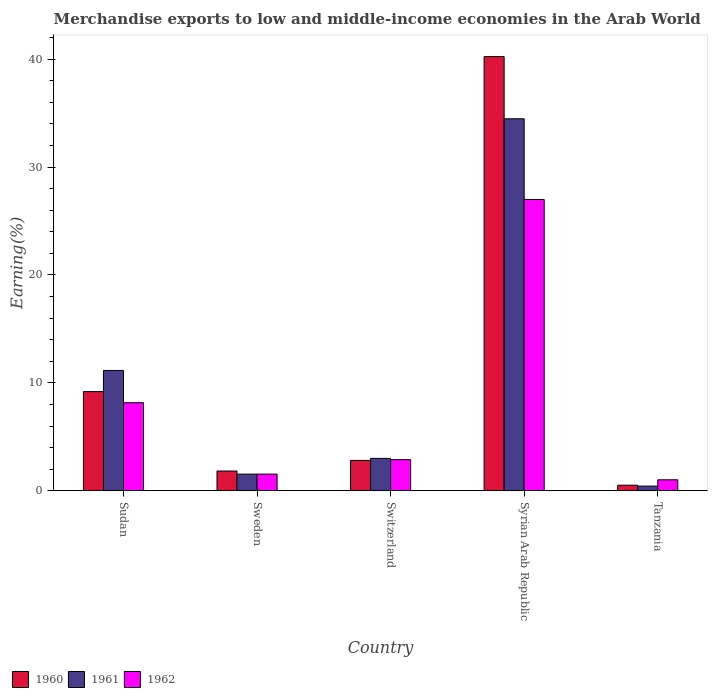What is the label of the 5th group of bars from the left?
Provide a succinct answer. Tanzania. What is the percentage of amount earned from merchandise exports in 1960 in Syrian Arab Republic?
Provide a succinct answer. 40.24. Across all countries, what is the maximum percentage of amount earned from merchandise exports in 1960?
Offer a very short reply. 40.24. Across all countries, what is the minimum percentage of amount earned from merchandise exports in 1962?
Your answer should be compact. 1.02. In which country was the percentage of amount earned from merchandise exports in 1961 maximum?
Keep it short and to the point. Syrian Arab Republic. In which country was the percentage of amount earned from merchandise exports in 1962 minimum?
Ensure brevity in your answer.  Tanzania. What is the total percentage of amount earned from merchandise exports in 1960 in the graph?
Offer a very short reply. 54.6. What is the difference between the percentage of amount earned from merchandise exports in 1961 in Sweden and that in Tanzania?
Ensure brevity in your answer.  1.11. What is the difference between the percentage of amount earned from merchandise exports in 1962 in Sudan and the percentage of amount earned from merchandise exports in 1961 in Syrian Arab Republic?
Keep it short and to the point. -26.32. What is the average percentage of amount earned from merchandise exports in 1962 per country?
Provide a succinct answer. 8.12. What is the difference between the percentage of amount earned from merchandise exports of/in 1962 and percentage of amount earned from merchandise exports of/in 1960 in Sudan?
Your response must be concise. -1.03. What is the ratio of the percentage of amount earned from merchandise exports in 1962 in Sudan to that in Switzerland?
Make the answer very short. 2.83. Is the percentage of amount earned from merchandise exports in 1961 in Switzerland less than that in Tanzania?
Your response must be concise. No. Is the difference between the percentage of amount earned from merchandise exports in 1962 in Sudan and Tanzania greater than the difference between the percentage of amount earned from merchandise exports in 1960 in Sudan and Tanzania?
Give a very brief answer. No. What is the difference between the highest and the second highest percentage of amount earned from merchandise exports in 1961?
Ensure brevity in your answer.  -31.48. What is the difference between the highest and the lowest percentage of amount earned from merchandise exports in 1962?
Make the answer very short. 25.98. In how many countries, is the percentage of amount earned from merchandise exports in 1961 greater than the average percentage of amount earned from merchandise exports in 1961 taken over all countries?
Your answer should be compact. 2. What does the 2nd bar from the left in Syrian Arab Republic represents?
Offer a terse response. 1961. What does the 2nd bar from the right in Sudan represents?
Your answer should be compact. 1961. How many bars are there?
Offer a terse response. 15. Are all the bars in the graph horizontal?
Your answer should be very brief. No. How many countries are there in the graph?
Provide a short and direct response. 5. Does the graph contain grids?
Keep it short and to the point. No. How many legend labels are there?
Provide a short and direct response. 3. What is the title of the graph?
Make the answer very short. Merchandise exports to low and middle-income economies in the Arab World. Does "2013" appear as one of the legend labels in the graph?
Your answer should be compact. No. What is the label or title of the Y-axis?
Offer a very short reply. Earning(%). What is the Earning(%) of 1960 in Sudan?
Provide a succinct answer. 9.19. What is the Earning(%) of 1961 in Sudan?
Offer a terse response. 11.15. What is the Earning(%) in 1962 in Sudan?
Provide a succinct answer. 8.16. What is the Earning(%) in 1960 in Sweden?
Your answer should be very brief. 1.83. What is the Earning(%) of 1961 in Sweden?
Offer a very short reply. 1.54. What is the Earning(%) of 1962 in Sweden?
Your response must be concise. 1.55. What is the Earning(%) in 1960 in Switzerland?
Offer a very short reply. 2.82. What is the Earning(%) in 1961 in Switzerland?
Your answer should be compact. 3. What is the Earning(%) in 1962 in Switzerland?
Make the answer very short. 2.89. What is the Earning(%) of 1960 in Syrian Arab Republic?
Your answer should be compact. 40.24. What is the Earning(%) of 1961 in Syrian Arab Republic?
Your answer should be compact. 34.48. What is the Earning(%) of 1962 in Syrian Arab Republic?
Offer a terse response. 27. What is the Earning(%) in 1960 in Tanzania?
Keep it short and to the point. 0.52. What is the Earning(%) of 1961 in Tanzania?
Give a very brief answer. 0.43. What is the Earning(%) of 1962 in Tanzania?
Your answer should be compact. 1.02. Across all countries, what is the maximum Earning(%) in 1960?
Keep it short and to the point. 40.24. Across all countries, what is the maximum Earning(%) in 1961?
Your answer should be compact. 34.48. Across all countries, what is the maximum Earning(%) of 1962?
Keep it short and to the point. 27. Across all countries, what is the minimum Earning(%) of 1960?
Your answer should be compact. 0.52. Across all countries, what is the minimum Earning(%) in 1961?
Ensure brevity in your answer.  0.43. Across all countries, what is the minimum Earning(%) of 1962?
Offer a very short reply. 1.02. What is the total Earning(%) in 1960 in the graph?
Offer a very short reply. 54.6. What is the total Earning(%) of 1961 in the graph?
Your response must be concise. 50.62. What is the total Earning(%) in 1962 in the graph?
Your answer should be compact. 40.62. What is the difference between the Earning(%) of 1960 in Sudan and that in Sweden?
Provide a succinct answer. 7.36. What is the difference between the Earning(%) of 1961 in Sudan and that in Sweden?
Give a very brief answer. 9.61. What is the difference between the Earning(%) of 1962 in Sudan and that in Sweden?
Provide a succinct answer. 6.62. What is the difference between the Earning(%) in 1960 in Sudan and that in Switzerland?
Give a very brief answer. 6.37. What is the difference between the Earning(%) in 1961 in Sudan and that in Switzerland?
Offer a terse response. 8.15. What is the difference between the Earning(%) in 1962 in Sudan and that in Switzerland?
Ensure brevity in your answer.  5.28. What is the difference between the Earning(%) of 1960 in Sudan and that in Syrian Arab Republic?
Offer a terse response. -31.05. What is the difference between the Earning(%) in 1961 in Sudan and that in Syrian Arab Republic?
Offer a terse response. -23.32. What is the difference between the Earning(%) of 1962 in Sudan and that in Syrian Arab Republic?
Offer a very short reply. -18.84. What is the difference between the Earning(%) in 1960 in Sudan and that in Tanzania?
Keep it short and to the point. 8.67. What is the difference between the Earning(%) in 1961 in Sudan and that in Tanzania?
Ensure brevity in your answer.  10.72. What is the difference between the Earning(%) in 1962 in Sudan and that in Tanzania?
Provide a succinct answer. 7.15. What is the difference between the Earning(%) in 1960 in Sweden and that in Switzerland?
Your answer should be very brief. -0.99. What is the difference between the Earning(%) in 1961 in Sweden and that in Switzerland?
Your answer should be very brief. -1.46. What is the difference between the Earning(%) of 1962 in Sweden and that in Switzerland?
Offer a very short reply. -1.34. What is the difference between the Earning(%) of 1960 in Sweden and that in Syrian Arab Republic?
Make the answer very short. -38.41. What is the difference between the Earning(%) of 1961 in Sweden and that in Syrian Arab Republic?
Provide a short and direct response. -32.94. What is the difference between the Earning(%) in 1962 in Sweden and that in Syrian Arab Republic?
Your answer should be very brief. -25.45. What is the difference between the Earning(%) of 1960 in Sweden and that in Tanzania?
Provide a short and direct response. 1.31. What is the difference between the Earning(%) of 1961 in Sweden and that in Tanzania?
Keep it short and to the point. 1.11. What is the difference between the Earning(%) in 1962 in Sweden and that in Tanzania?
Provide a succinct answer. 0.53. What is the difference between the Earning(%) of 1960 in Switzerland and that in Syrian Arab Republic?
Make the answer very short. -37.43. What is the difference between the Earning(%) of 1961 in Switzerland and that in Syrian Arab Republic?
Offer a terse response. -31.48. What is the difference between the Earning(%) in 1962 in Switzerland and that in Syrian Arab Republic?
Provide a short and direct response. -24.12. What is the difference between the Earning(%) in 1960 in Switzerland and that in Tanzania?
Keep it short and to the point. 2.3. What is the difference between the Earning(%) in 1961 in Switzerland and that in Tanzania?
Provide a short and direct response. 2.57. What is the difference between the Earning(%) of 1962 in Switzerland and that in Tanzania?
Ensure brevity in your answer.  1.87. What is the difference between the Earning(%) in 1960 in Syrian Arab Republic and that in Tanzania?
Your response must be concise. 39.72. What is the difference between the Earning(%) in 1961 in Syrian Arab Republic and that in Tanzania?
Offer a terse response. 34.05. What is the difference between the Earning(%) of 1962 in Syrian Arab Republic and that in Tanzania?
Give a very brief answer. 25.98. What is the difference between the Earning(%) in 1960 in Sudan and the Earning(%) in 1961 in Sweden?
Ensure brevity in your answer.  7.65. What is the difference between the Earning(%) in 1960 in Sudan and the Earning(%) in 1962 in Sweden?
Ensure brevity in your answer.  7.64. What is the difference between the Earning(%) of 1961 in Sudan and the Earning(%) of 1962 in Sweden?
Offer a terse response. 9.61. What is the difference between the Earning(%) in 1960 in Sudan and the Earning(%) in 1961 in Switzerland?
Your response must be concise. 6.19. What is the difference between the Earning(%) in 1960 in Sudan and the Earning(%) in 1962 in Switzerland?
Give a very brief answer. 6.31. What is the difference between the Earning(%) of 1961 in Sudan and the Earning(%) of 1962 in Switzerland?
Your answer should be compact. 8.27. What is the difference between the Earning(%) of 1960 in Sudan and the Earning(%) of 1961 in Syrian Arab Republic?
Your response must be concise. -25.29. What is the difference between the Earning(%) of 1960 in Sudan and the Earning(%) of 1962 in Syrian Arab Republic?
Your answer should be compact. -17.81. What is the difference between the Earning(%) in 1961 in Sudan and the Earning(%) in 1962 in Syrian Arab Republic?
Your answer should be compact. -15.85. What is the difference between the Earning(%) of 1960 in Sudan and the Earning(%) of 1961 in Tanzania?
Make the answer very short. 8.76. What is the difference between the Earning(%) in 1960 in Sudan and the Earning(%) in 1962 in Tanzania?
Ensure brevity in your answer.  8.17. What is the difference between the Earning(%) in 1961 in Sudan and the Earning(%) in 1962 in Tanzania?
Ensure brevity in your answer.  10.14. What is the difference between the Earning(%) of 1960 in Sweden and the Earning(%) of 1961 in Switzerland?
Offer a terse response. -1.17. What is the difference between the Earning(%) in 1960 in Sweden and the Earning(%) in 1962 in Switzerland?
Keep it short and to the point. -1.05. What is the difference between the Earning(%) of 1961 in Sweden and the Earning(%) of 1962 in Switzerland?
Keep it short and to the point. -1.34. What is the difference between the Earning(%) in 1960 in Sweden and the Earning(%) in 1961 in Syrian Arab Republic?
Ensure brevity in your answer.  -32.65. What is the difference between the Earning(%) of 1960 in Sweden and the Earning(%) of 1962 in Syrian Arab Republic?
Keep it short and to the point. -25.17. What is the difference between the Earning(%) of 1961 in Sweden and the Earning(%) of 1962 in Syrian Arab Republic?
Offer a very short reply. -25.46. What is the difference between the Earning(%) of 1960 in Sweden and the Earning(%) of 1961 in Tanzania?
Your response must be concise. 1.4. What is the difference between the Earning(%) in 1960 in Sweden and the Earning(%) in 1962 in Tanzania?
Offer a terse response. 0.81. What is the difference between the Earning(%) in 1961 in Sweden and the Earning(%) in 1962 in Tanzania?
Offer a very short reply. 0.53. What is the difference between the Earning(%) of 1960 in Switzerland and the Earning(%) of 1961 in Syrian Arab Republic?
Your answer should be compact. -31.66. What is the difference between the Earning(%) in 1960 in Switzerland and the Earning(%) in 1962 in Syrian Arab Republic?
Provide a succinct answer. -24.18. What is the difference between the Earning(%) of 1961 in Switzerland and the Earning(%) of 1962 in Syrian Arab Republic?
Ensure brevity in your answer.  -24. What is the difference between the Earning(%) in 1960 in Switzerland and the Earning(%) in 1961 in Tanzania?
Offer a very short reply. 2.38. What is the difference between the Earning(%) in 1960 in Switzerland and the Earning(%) in 1962 in Tanzania?
Your answer should be very brief. 1.8. What is the difference between the Earning(%) of 1961 in Switzerland and the Earning(%) of 1962 in Tanzania?
Offer a terse response. 1.99. What is the difference between the Earning(%) of 1960 in Syrian Arab Republic and the Earning(%) of 1961 in Tanzania?
Provide a short and direct response. 39.81. What is the difference between the Earning(%) in 1960 in Syrian Arab Republic and the Earning(%) in 1962 in Tanzania?
Make the answer very short. 39.23. What is the difference between the Earning(%) in 1961 in Syrian Arab Republic and the Earning(%) in 1962 in Tanzania?
Provide a short and direct response. 33.46. What is the average Earning(%) in 1960 per country?
Your answer should be compact. 10.92. What is the average Earning(%) of 1961 per country?
Provide a short and direct response. 10.12. What is the average Earning(%) of 1962 per country?
Ensure brevity in your answer.  8.12. What is the difference between the Earning(%) in 1960 and Earning(%) in 1961 in Sudan?
Offer a terse response. -1.96. What is the difference between the Earning(%) of 1960 and Earning(%) of 1962 in Sudan?
Your answer should be very brief. 1.03. What is the difference between the Earning(%) of 1961 and Earning(%) of 1962 in Sudan?
Your response must be concise. 2.99. What is the difference between the Earning(%) of 1960 and Earning(%) of 1961 in Sweden?
Offer a very short reply. 0.29. What is the difference between the Earning(%) of 1960 and Earning(%) of 1962 in Sweden?
Keep it short and to the point. 0.28. What is the difference between the Earning(%) in 1961 and Earning(%) in 1962 in Sweden?
Make the answer very short. -0. What is the difference between the Earning(%) of 1960 and Earning(%) of 1961 in Switzerland?
Offer a terse response. -0.19. What is the difference between the Earning(%) of 1960 and Earning(%) of 1962 in Switzerland?
Ensure brevity in your answer.  -0.07. What is the difference between the Earning(%) of 1961 and Earning(%) of 1962 in Switzerland?
Give a very brief answer. 0.12. What is the difference between the Earning(%) in 1960 and Earning(%) in 1961 in Syrian Arab Republic?
Ensure brevity in your answer.  5.76. What is the difference between the Earning(%) in 1960 and Earning(%) in 1962 in Syrian Arab Republic?
Your response must be concise. 13.24. What is the difference between the Earning(%) in 1961 and Earning(%) in 1962 in Syrian Arab Republic?
Your answer should be compact. 7.48. What is the difference between the Earning(%) in 1960 and Earning(%) in 1961 in Tanzania?
Provide a short and direct response. 0.08. What is the difference between the Earning(%) in 1960 and Earning(%) in 1962 in Tanzania?
Offer a very short reply. -0.5. What is the difference between the Earning(%) in 1961 and Earning(%) in 1962 in Tanzania?
Your answer should be compact. -0.58. What is the ratio of the Earning(%) in 1960 in Sudan to that in Sweden?
Give a very brief answer. 5.02. What is the ratio of the Earning(%) of 1961 in Sudan to that in Sweden?
Keep it short and to the point. 7.22. What is the ratio of the Earning(%) in 1962 in Sudan to that in Sweden?
Ensure brevity in your answer.  5.28. What is the ratio of the Earning(%) of 1960 in Sudan to that in Switzerland?
Provide a short and direct response. 3.26. What is the ratio of the Earning(%) in 1961 in Sudan to that in Switzerland?
Offer a very short reply. 3.71. What is the ratio of the Earning(%) of 1962 in Sudan to that in Switzerland?
Provide a short and direct response. 2.83. What is the ratio of the Earning(%) of 1960 in Sudan to that in Syrian Arab Republic?
Provide a short and direct response. 0.23. What is the ratio of the Earning(%) of 1961 in Sudan to that in Syrian Arab Republic?
Offer a terse response. 0.32. What is the ratio of the Earning(%) in 1962 in Sudan to that in Syrian Arab Republic?
Your answer should be compact. 0.3. What is the ratio of the Earning(%) of 1960 in Sudan to that in Tanzania?
Offer a terse response. 17.72. What is the ratio of the Earning(%) of 1961 in Sudan to that in Tanzania?
Make the answer very short. 25.69. What is the ratio of the Earning(%) of 1962 in Sudan to that in Tanzania?
Ensure brevity in your answer.  8.02. What is the ratio of the Earning(%) of 1960 in Sweden to that in Switzerland?
Offer a very short reply. 0.65. What is the ratio of the Earning(%) of 1961 in Sweden to that in Switzerland?
Your response must be concise. 0.51. What is the ratio of the Earning(%) in 1962 in Sweden to that in Switzerland?
Your answer should be very brief. 0.54. What is the ratio of the Earning(%) of 1960 in Sweden to that in Syrian Arab Republic?
Ensure brevity in your answer.  0.05. What is the ratio of the Earning(%) in 1961 in Sweden to that in Syrian Arab Republic?
Your response must be concise. 0.04. What is the ratio of the Earning(%) in 1962 in Sweden to that in Syrian Arab Republic?
Provide a succinct answer. 0.06. What is the ratio of the Earning(%) of 1960 in Sweden to that in Tanzania?
Your response must be concise. 3.53. What is the ratio of the Earning(%) in 1961 in Sweden to that in Tanzania?
Your answer should be compact. 3.56. What is the ratio of the Earning(%) of 1962 in Sweden to that in Tanzania?
Your answer should be compact. 1.52. What is the ratio of the Earning(%) in 1960 in Switzerland to that in Syrian Arab Republic?
Your response must be concise. 0.07. What is the ratio of the Earning(%) of 1961 in Switzerland to that in Syrian Arab Republic?
Your answer should be very brief. 0.09. What is the ratio of the Earning(%) of 1962 in Switzerland to that in Syrian Arab Republic?
Keep it short and to the point. 0.11. What is the ratio of the Earning(%) of 1960 in Switzerland to that in Tanzania?
Make the answer very short. 5.43. What is the ratio of the Earning(%) of 1961 in Switzerland to that in Tanzania?
Make the answer very short. 6.92. What is the ratio of the Earning(%) of 1962 in Switzerland to that in Tanzania?
Provide a short and direct response. 2.84. What is the ratio of the Earning(%) of 1960 in Syrian Arab Republic to that in Tanzania?
Provide a succinct answer. 77.57. What is the ratio of the Earning(%) of 1961 in Syrian Arab Republic to that in Tanzania?
Offer a very short reply. 79.42. What is the ratio of the Earning(%) of 1962 in Syrian Arab Republic to that in Tanzania?
Provide a short and direct response. 26.53. What is the difference between the highest and the second highest Earning(%) of 1960?
Make the answer very short. 31.05. What is the difference between the highest and the second highest Earning(%) in 1961?
Your answer should be very brief. 23.32. What is the difference between the highest and the second highest Earning(%) in 1962?
Provide a succinct answer. 18.84. What is the difference between the highest and the lowest Earning(%) of 1960?
Make the answer very short. 39.72. What is the difference between the highest and the lowest Earning(%) of 1961?
Offer a terse response. 34.05. What is the difference between the highest and the lowest Earning(%) in 1962?
Provide a succinct answer. 25.98. 